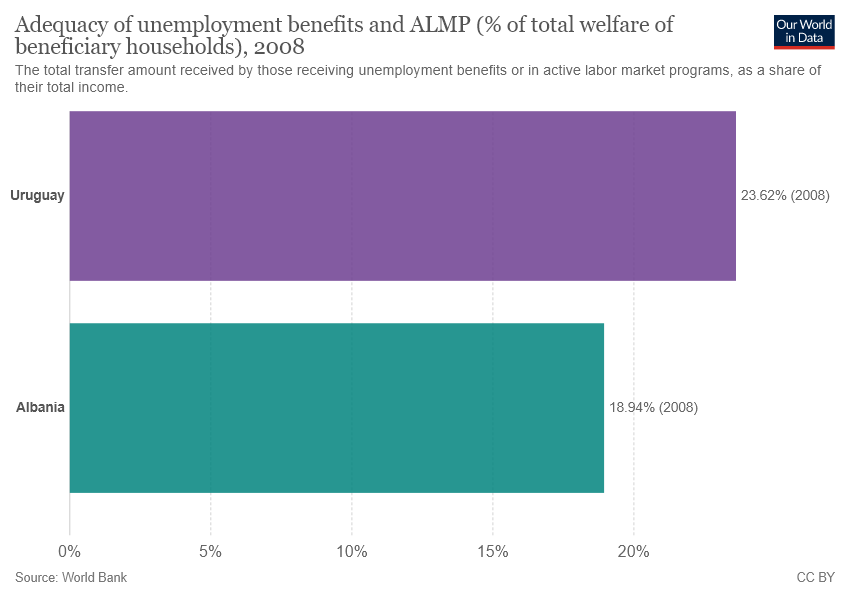Identify some key points in this picture. Uruguay is the country represented by the purple bar. The median in the percentage of adequacy of unemployment benefits is 0.2128. 